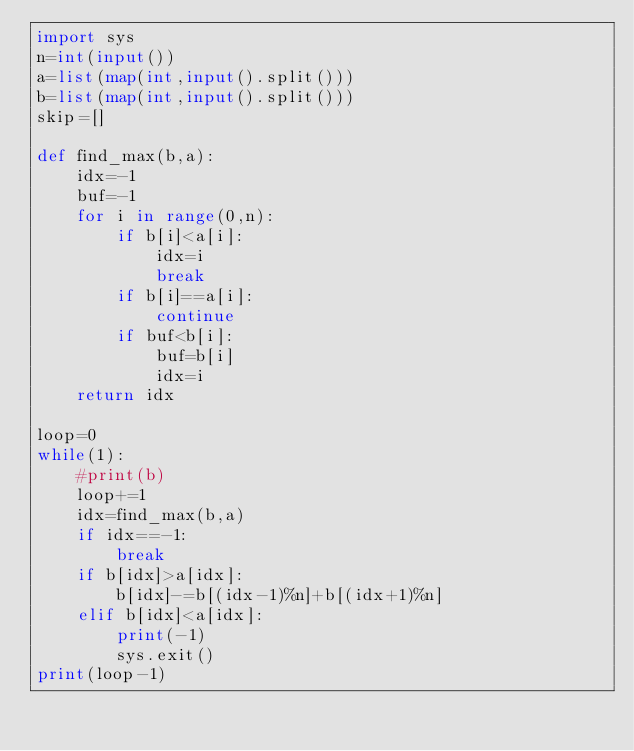<code> <loc_0><loc_0><loc_500><loc_500><_Python_>import sys
n=int(input())
a=list(map(int,input().split()))
b=list(map(int,input().split()))
skip=[]

def find_max(b,a):
    idx=-1
    buf=-1
    for i in range(0,n):
        if b[i]<a[i]:
            idx=i
            break
        if b[i]==a[i]:
            continue
        if buf<b[i]:
            buf=b[i]
            idx=i
    return idx

loop=0 
while(1):
    #print(b)
    loop+=1
    idx=find_max(b,a)
    if idx==-1:
        break
    if b[idx]>a[idx]:
        b[idx]-=b[(idx-1)%n]+b[(idx+1)%n]
    elif b[idx]<a[idx]:
        print(-1)
        sys.exit()
print(loop-1)</code> 